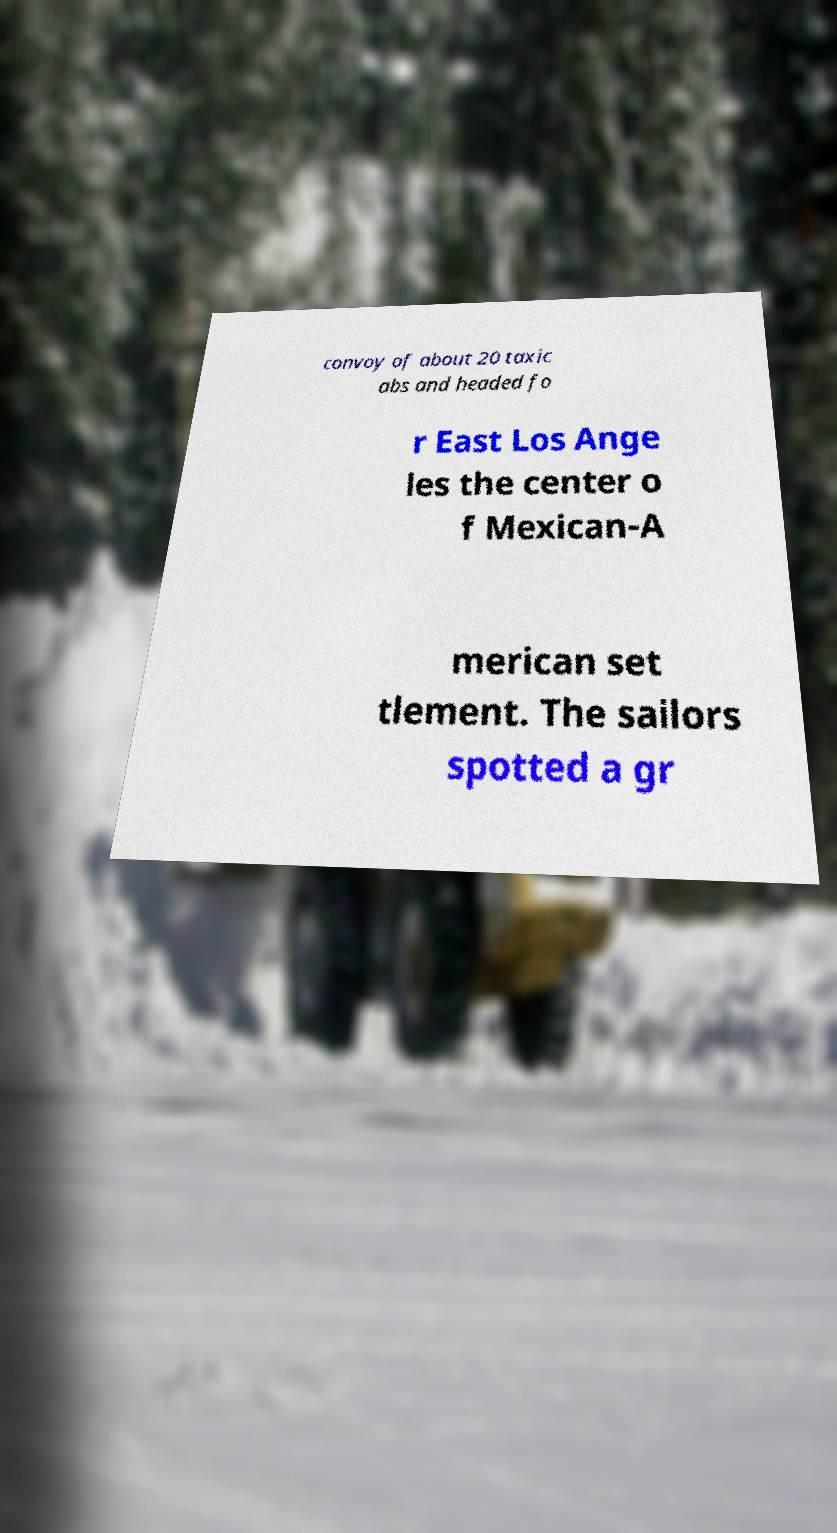I need the written content from this picture converted into text. Can you do that? convoy of about 20 taxic abs and headed fo r East Los Ange les the center o f Mexican-A merican set tlement. The sailors spotted a gr 